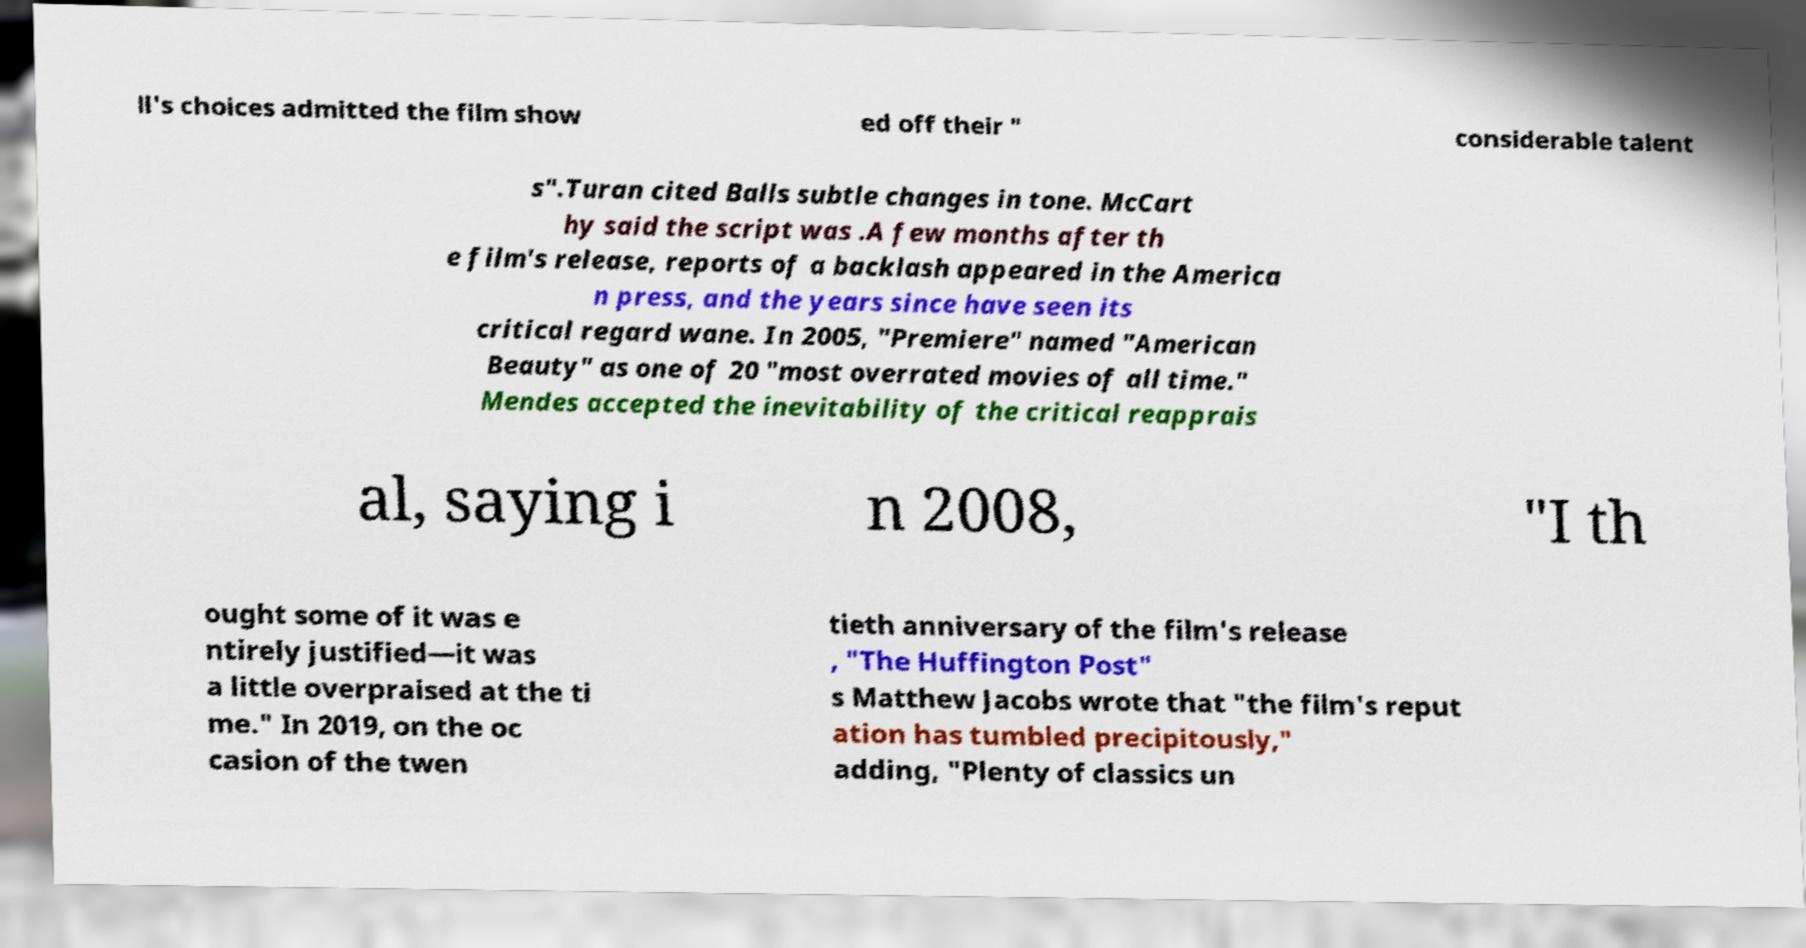Can you accurately transcribe the text from the provided image for me? ll's choices admitted the film show ed off their " considerable talent s".Turan cited Balls subtle changes in tone. McCart hy said the script was .A few months after th e film's release, reports of a backlash appeared in the America n press, and the years since have seen its critical regard wane. In 2005, "Premiere" named "American Beauty" as one of 20 "most overrated movies of all time." Mendes accepted the inevitability of the critical reapprais al, saying i n 2008, "I th ought some of it was e ntirely justified—it was a little overpraised at the ti me." In 2019, on the oc casion of the twen tieth anniversary of the film's release , "The Huffington Post" s Matthew Jacobs wrote that "the film's reput ation has tumbled precipitously," adding, "Plenty of classics un 